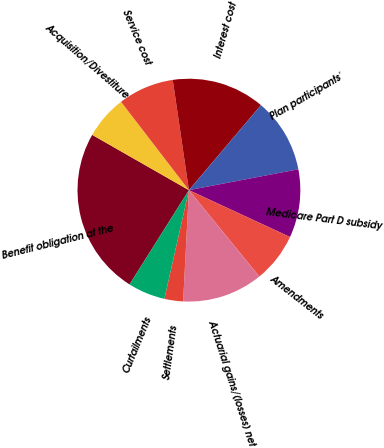<chart> <loc_0><loc_0><loc_500><loc_500><pie_chart><fcel>Benefit obligation at the<fcel>Acquisition/Divestiture<fcel>Service cost<fcel>Interest cost<fcel>Plan participants'<fcel>Medicare Part D subsidy<fcel>Amendments<fcel>Actuarial gains/(losses) net<fcel>Settlements<fcel>Curtailments<nl><fcel>24.32%<fcel>6.31%<fcel>8.11%<fcel>13.51%<fcel>10.81%<fcel>9.91%<fcel>7.21%<fcel>11.71%<fcel>2.71%<fcel>5.41%<nl></chart> 